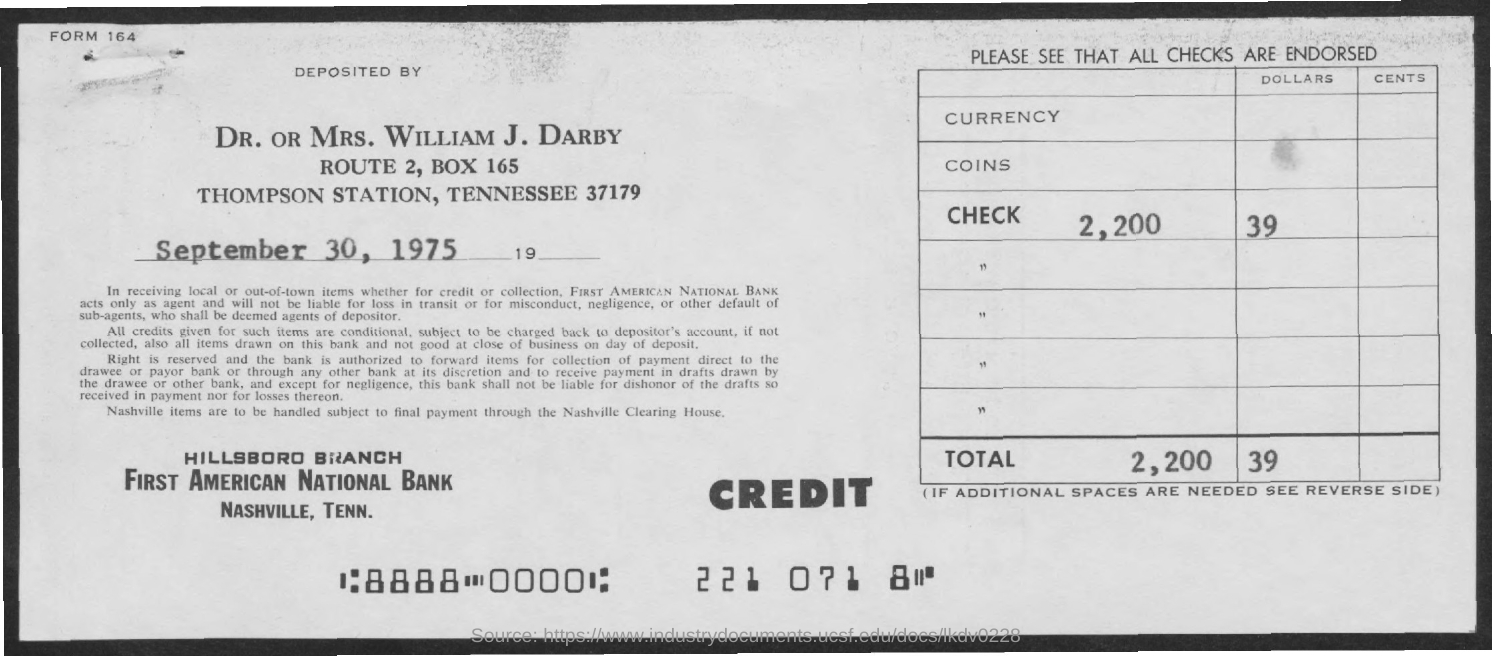Outline some significant characteristics in this image. First American National Bank is the name of the bank. The date mentioned is September 30, 1975. First American National Bank is located in Nashville, Tennessee. The station mentioned is named Thompson Station. The cheque is deposited by Dr. or Mrs. William J. Darby. 